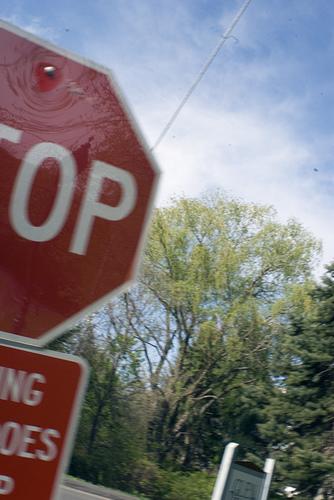What does the sign under the stop say?
Concise answer only. Unclear. What is a driver supposed to do when they see this sign?
Concise answer only. Stop. What color is the sign?
Write a very short answer. Red. 